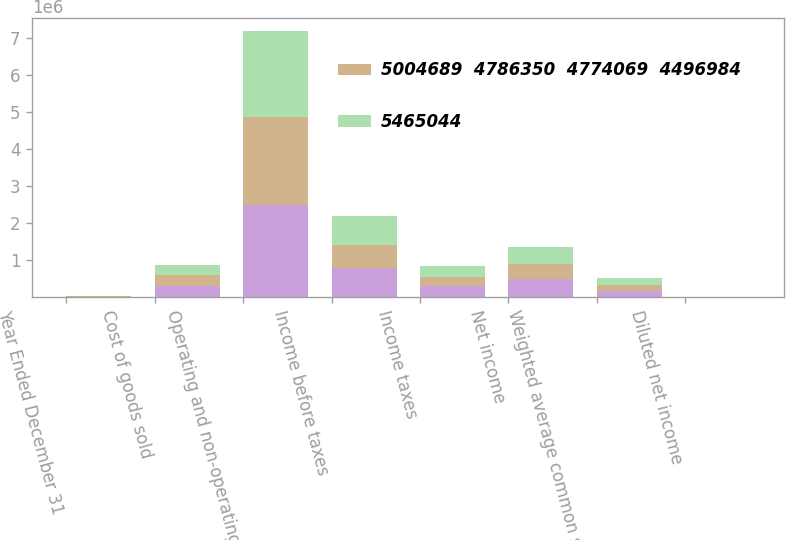<chart> <loc_0><loc_0><loc_500><loc_500><stacked_bar_chart><ecel><fcel>Year Ended December 31<fcel>Cost of goods sold<fcel>Operating and non-operating<fcel>Income before taxes<fcel>Income taxes<fcel>Net income<fcel>Weighted average common shares<fcel>Diluted net income<nl><fcel>nan<fcel>2010<fcel>286272<fcel>2.49116e+06<fcel>761783<fcel>286272<fcel>475511<fcel>158461<fcel>3<nl><fcel>5004689  4786350  4774069  4496984<fcel>2009<fcel>286272<fcel>2.3656e+06<fcel>644165<fcel>244590<fcel>399575<fcel>159707<fcel>2.5<nl><fcel>5465044<fcel>2006<fcel>286272<fcel>2.33358e+06<fcel>770916<fcel>295511<fcel>475405<fcel>172486<fcel>2.76<nl></chart> 